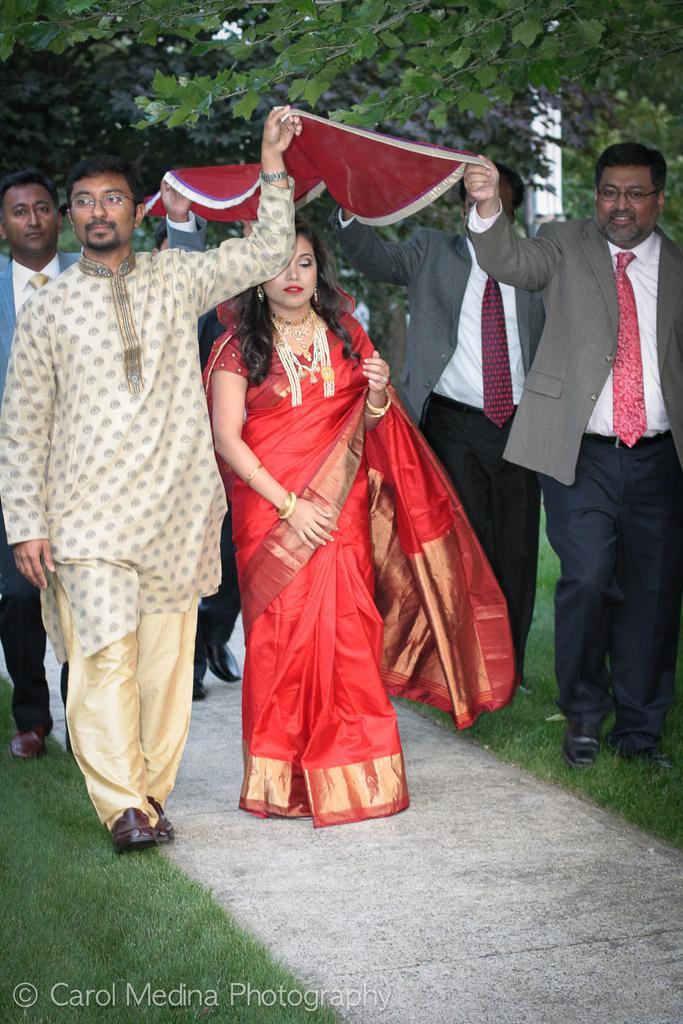Describe this image in one or two sentences. In this image there are some people who are walking and they are holding some cloth, and in the center there is one woman. At the bottom there is grass and a walkway, and in the background there are some trees. 